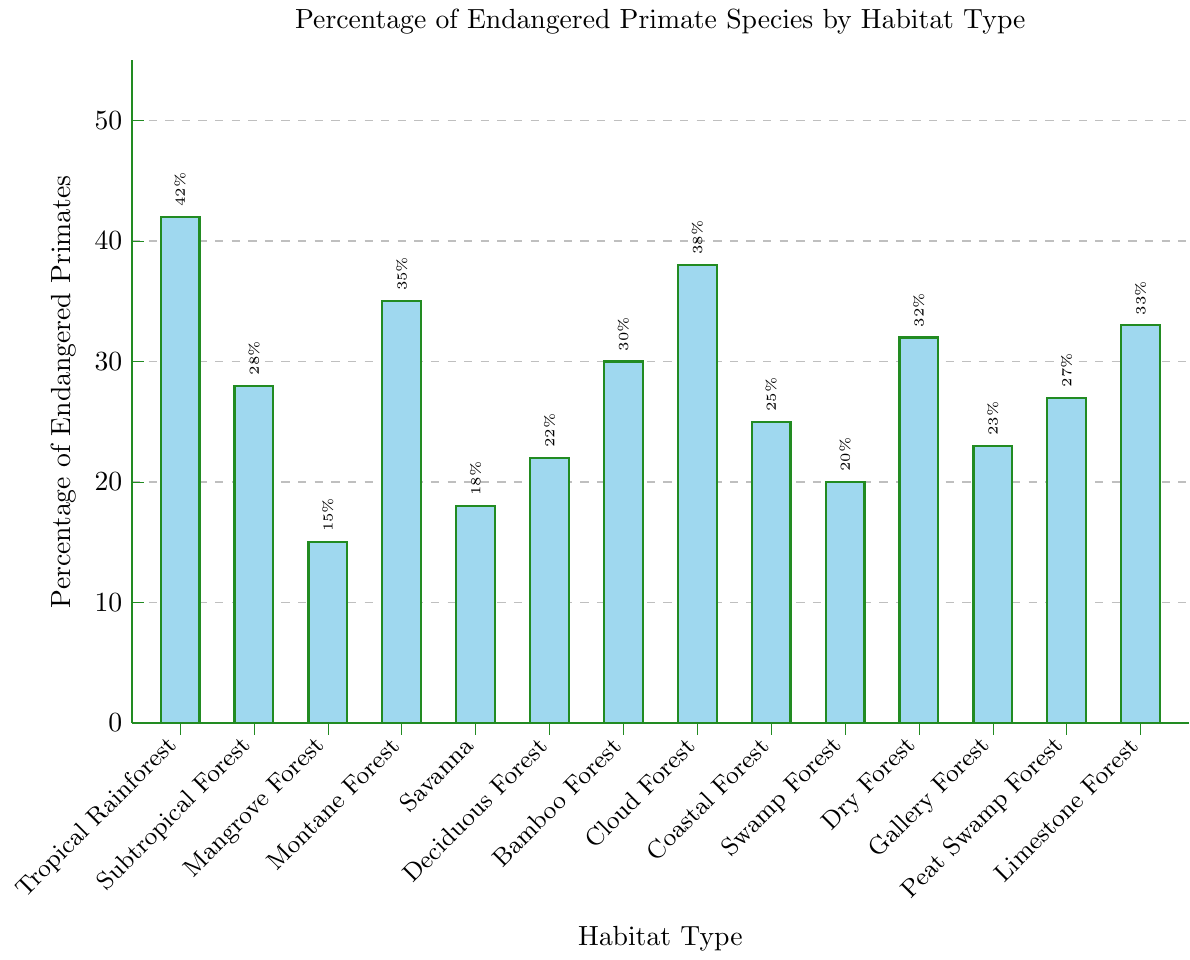What is the habitat type with the highest percentage of endangered primate species? The highest bar corresponds to the Tropical Rainforest habitat, which reaches 42%.
Answer: Tropical Rainforest Which habitat type has a lower percentage of endangered primate species, Mangrove Forest or Montane Forest? Mangrove Forest is noted at 15%, while Montane Forest is marked at 35%. 15% is less than 35%, so Mangrove Forest has a lower percentage.
Answer: Mangrove Forest By how much does the percentage of endangered primates in Subtropical Forest exceed that in Mangrove Forest? Subtropical Forest has a percentage of 28%, and Mangrove Forest has 15%. The difference is calculated as 28 - 15.
Answer: 13 What is the average percentage of endangered primate species across the habitats with more than 30% endangered primates? The relevant habitats are Tropical Rainforest (42%), Montane Forest (35%), Cloud Forest (38%), Dry Forest (32%), and Limestone Forest (33%). The sum of these values is 42 + 35 + 38 + 32 + 33 = 180. Dividing by 5 gives the average: 180 / 5.
Answer: 36 Which habitat types have a percentage of endangered primates greater than 25% but less than 35%? Habitats satisfying this condition are Subtropical Forest (28%), Bamboo Forest (30%), Peat Swamp Forest (27%), and Limestone Forest (33%).
Answer: Subtropical Forest, Bamboo Forest, Peat Swamp Forest, Limestone Forest What is the median percentage value of endangered primate species across all habitat types? The percentages in ascending order are: 15, 18, 20, 22, 23, 25, 27, 28, 30, 32, 33, 35, 38, 42. The median is the average of the 7th and 8th values (27 and 28). (27+28) / 2 = 27.5.
Answer: 27.5 How many habitat types have a percentage of endangered primates below the mean value? First, we calculate the mean value: Sum of all percentages is 15 + 18 + 20 + 22 + 23 + 25 + 27 + 28 + 30 + 32 + 33 + 35 + 38 + 42 = 388. There are 14 habitat types, so the mean is 388 / 14 = 27.71. Habitats below 27.71% are: Mangrove Forest, Savanna, Deciduous Forest, Coastal Forest, Swamp Forest, Peat Swamp Forest, Subtropical Forest. Total = 7.
Answer: 7 Between which two adjacent habitat types is the greatest difference in the percentage of endangered primates? Calculating the absolute differences between adjacent values: 42-28=14, 28-15=13, 15-35=20, 35-18=17, 18-22=4, 22-30=8, 30-38=8, 38-25=13, 25-20=5, 20-32=12, 32-23=9, 23-27=4, 27-33=6. The greatest difference is 20 between Mangrove Forest (15) and Montane Forest (35).
Answer: Mangrove Forest and Montane Forest What is the total percentage of endangered primates in forest habitats (i.e., those containing the word 'Forest' in their names)? Adding the percentages of all such habitats: Tropical Rainforest (42) + Subtropical Forest (28) + Mangrove Forest (15) + Montane Forest (35) + Deciduous Forest (22) + Bamboo Forest (30) + Cloud Forest (38) + Coastal Forest (25) + Swamp Forest (20) + Dry Forest (32) + Gallery Forest (23) + Peat Swamp Forest (27) + Limestone Forest (33). Total = 42+28+15+35+22+30+38+25+20+32+23+27+33 = 370.
Answer: 370 